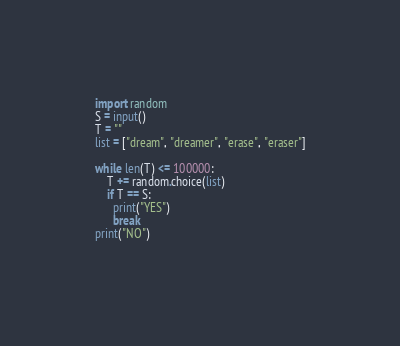<code> <loc_0><loc_0><loc_500><loc_500><_Python_>import random
S = input()
T = ""
list = ["dream", "dreamer", "erase", "eraser"]

while len(T) <= 100000:
	T += random.choice(list)
    if T == S:
      print("YES")
      break
print("NO")
     </code> 